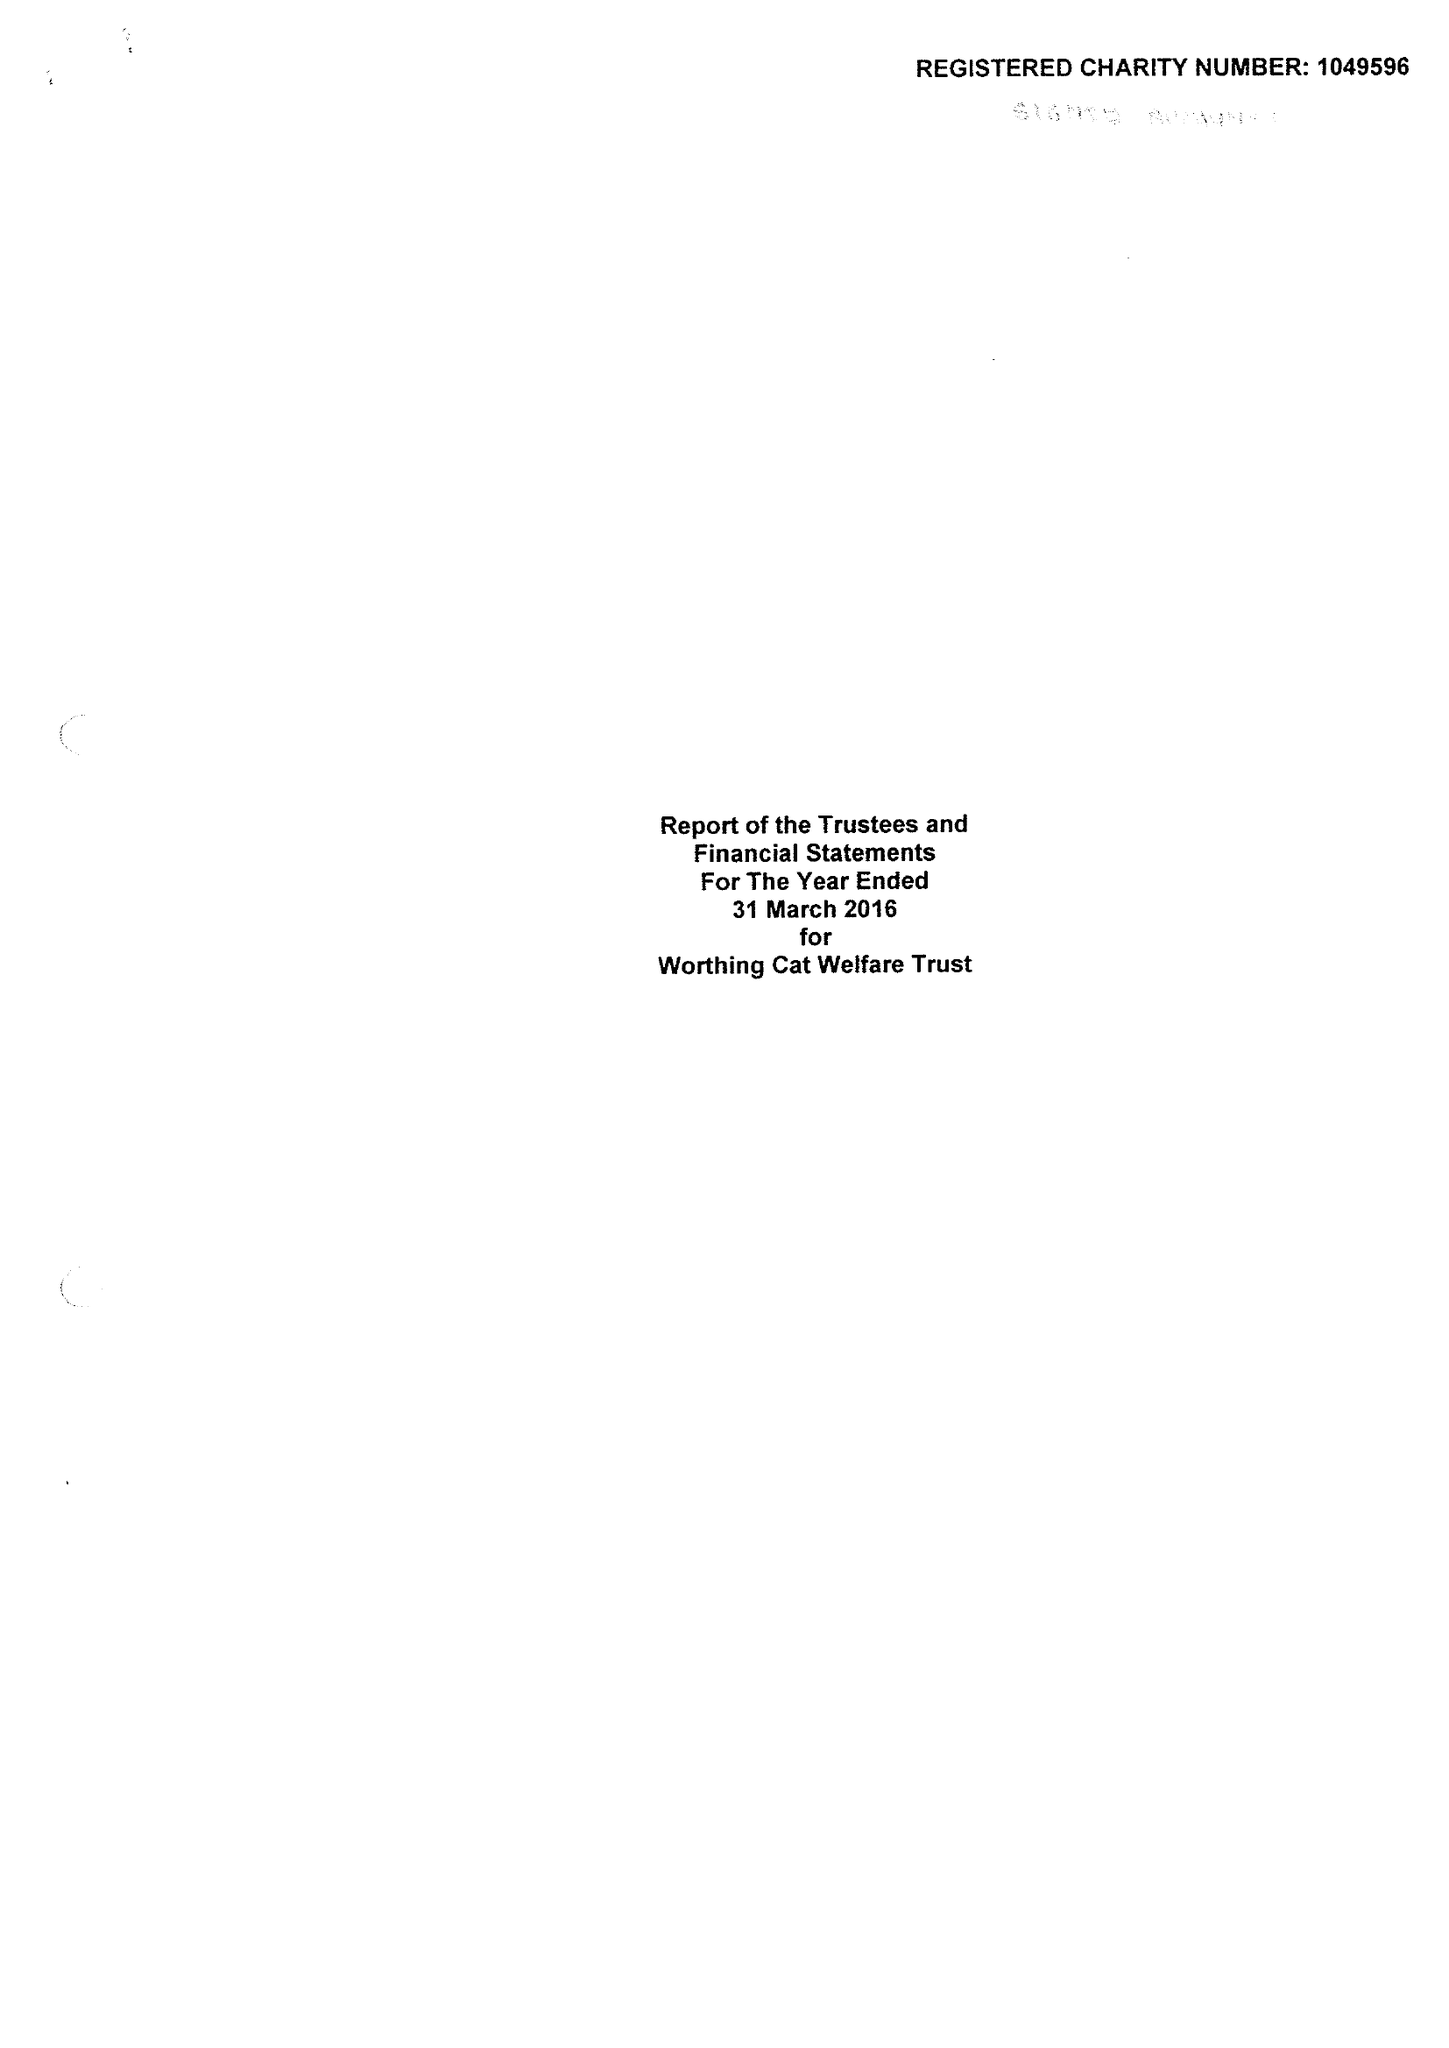What is the value for the income_annually_in_british_pounds?
Answer the question using a single word or phrase. 126380.00 